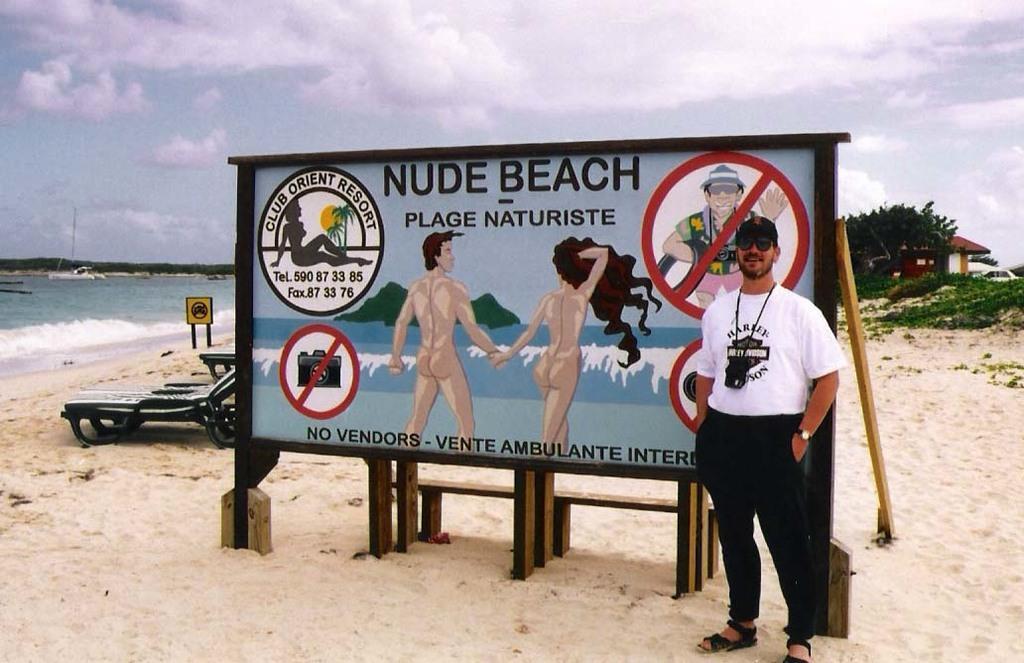Describe this image in one or two sentences. In this picture, there is a board in the beach. On the board, there are some pictures and text. Beside the board, there is a man wearing a white t shirt, black trousers and carrying a camera. At the bottom, there is sand. Towards the left, there is water, bench and a board. Towards the right, there is a house and plants. On the top, there is a sky. 